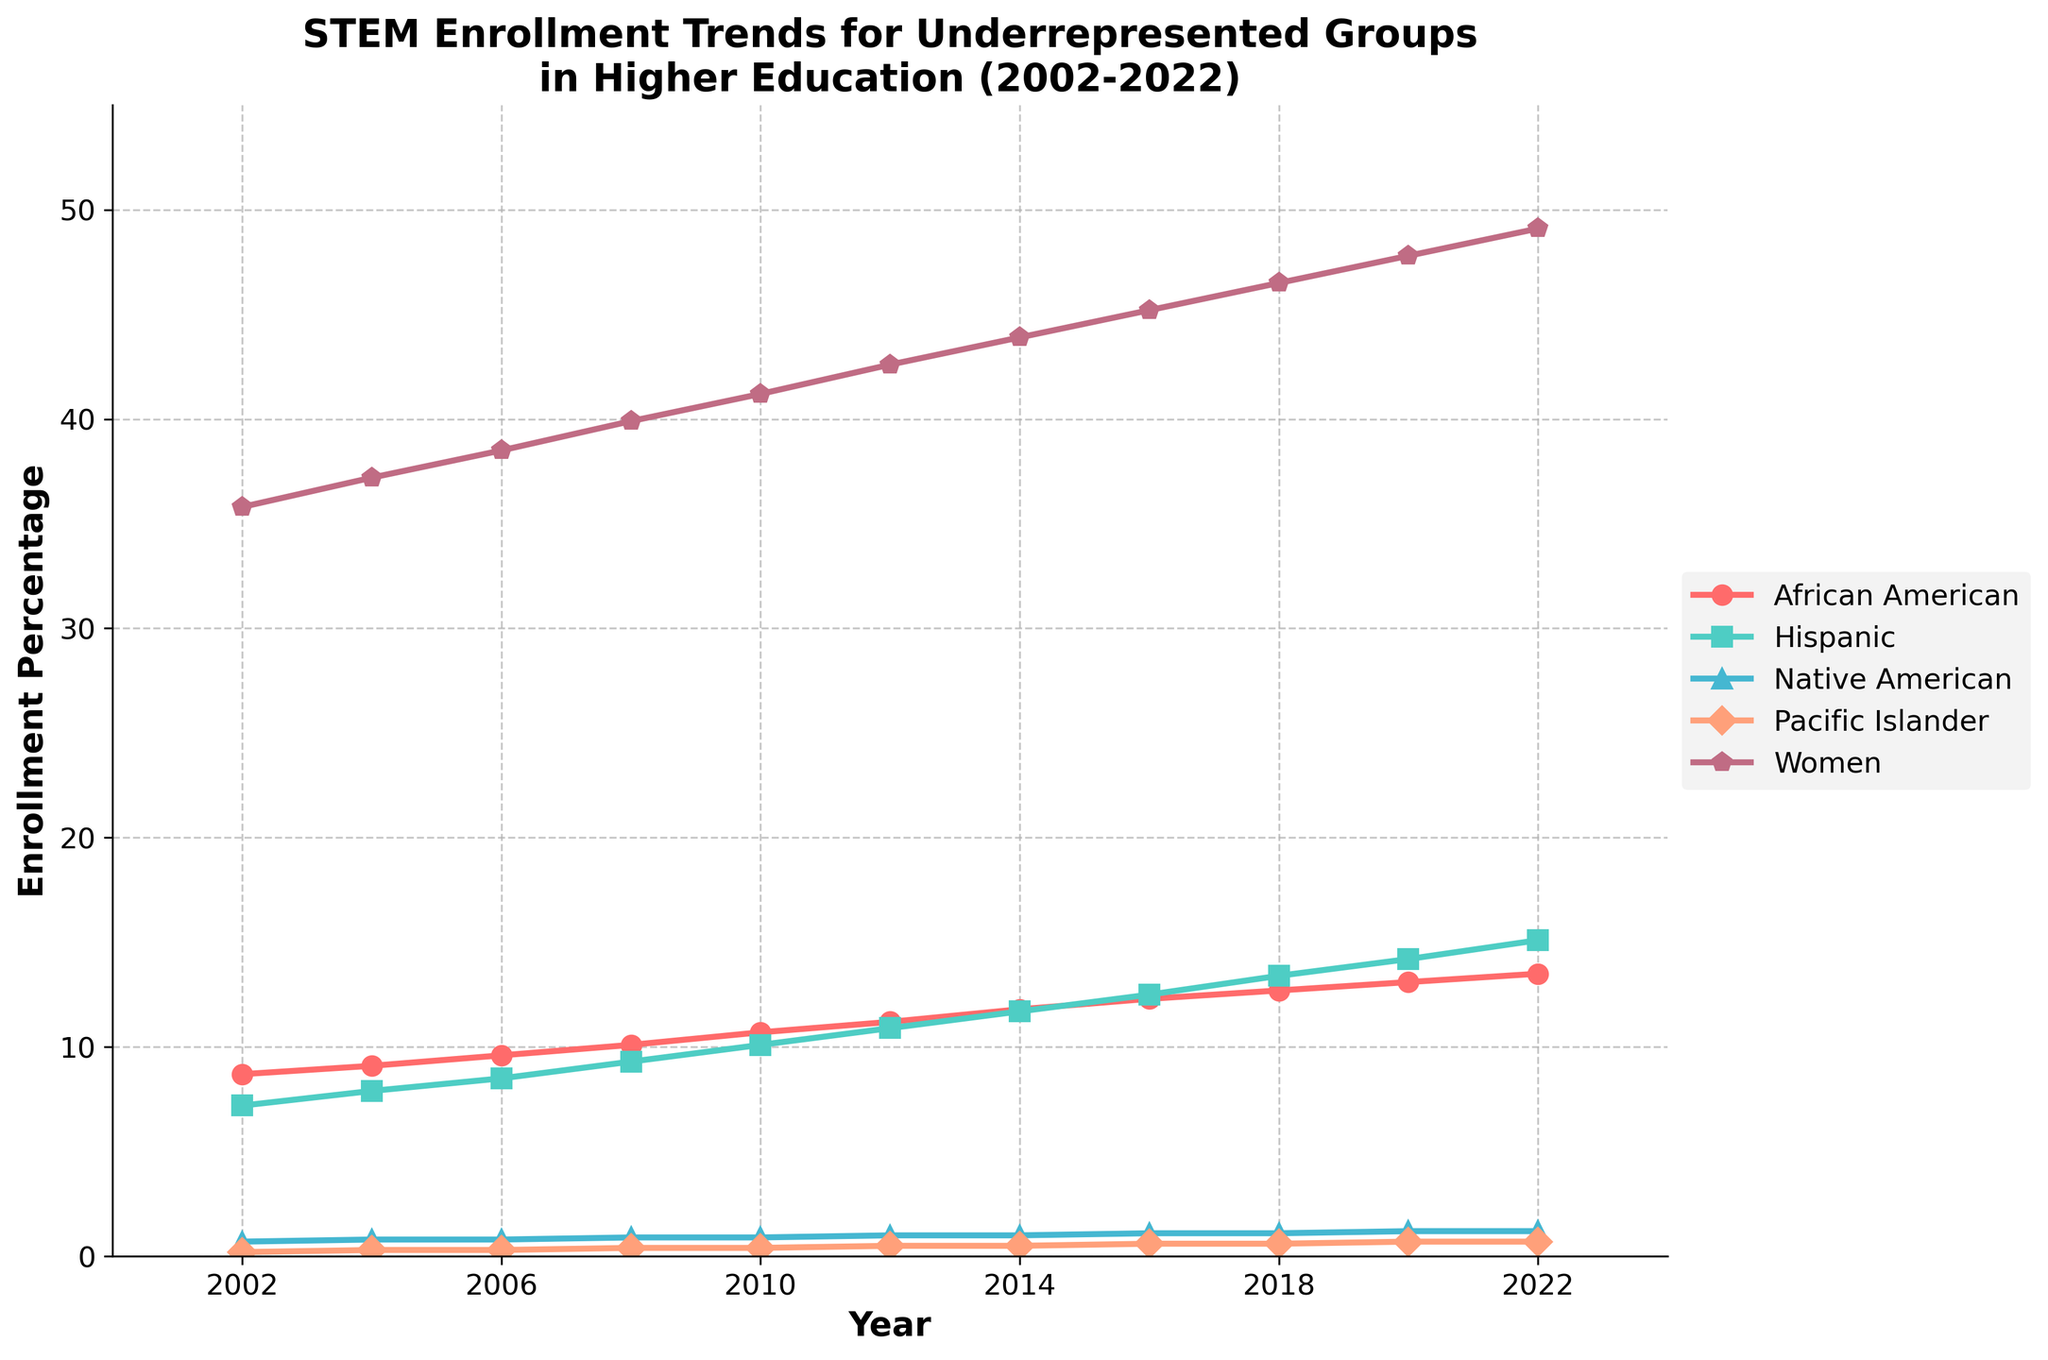What is the trend in the enrollment percentage for African Americans over the years? The line for African Americans shows a clear upward trend from 8.7% in 2002 to 13.5% in 2022.
Answer: Increasing By how much did Hispanic enrollment increase from 2002 to 2022? The Hispanic enrollment percentage increased from 7.2% in 2002 to 15.1% in 2022. The difference is 15.1% - 7.2% = 7.9%.
Answer: 7.9% Which underrepresented group had the smallest enrollment percentage throughout the years? The Native American group consistently had the smallest enrollment percentage, with values ranging from 0.7% to 1.2% between 2002 and 2022.
Answer: Native American In which year did Women surpass 45% enrollment in STEM fields? According to the line chart, Women surpassed 45% enrollment in the year 2016.
Answer: 2016 Between African Americans and Pacific Islanders, which group saw a larger increase in enrollment percentage from 2002 to 2022? African Americans increased from 8.7% to 13.5%, which is a 4.8% increase. Pacific Islanders increased from 0.2% to 0.7%, which is a 0.5% increase. Therefore, African Americans saw a larger increase.
Answer: African Americans What is the approximate average enrollment percentage for Native Americans over the 20 years? The percentages for Native Americans each year are: 0.7, 0.8, 0.8, 0.9, 0.9, 1.0, 1.0, 1.1, 1.1, 1.2, 1.2. Summing these gives 10.7. Dividing by 11 (number of data points) gives an average of approximately 0.97%.
Answer: 0.97% Which group had the second highest enrollment percentage in 2022 and what was it? In 2022, Hispanic students had the second highest enrollment percentage at 15.1%, only behind Women.
Answer: Hispanic with 15.1% Did any group experience a decrease in enrollment percentage over the years? Based on the figure, no group experienced a decline in enrollment percentages; all groups show an upward trend over the years.
Answer: No What was the enrollment percentage for Women in 2010, and how does it compare to the same year for African Americans? In 2010, Women had an enrollment percentage of 41.2%, while African Americans had 10.7%. The enrollment for Women was significantly higher.
Answer: Women: 41.2%, African Americans: 10.7% How does the trend for Native American enrollment compare to the trend for African American enrollment? Both groups show an upward trend. However, the increase for Native Americans is slight (0.7% to 1.2%), whereas African Americans had a more substantial increase (8.7% to 13.5%).
Answer: Both increasing, but African American more substantial 